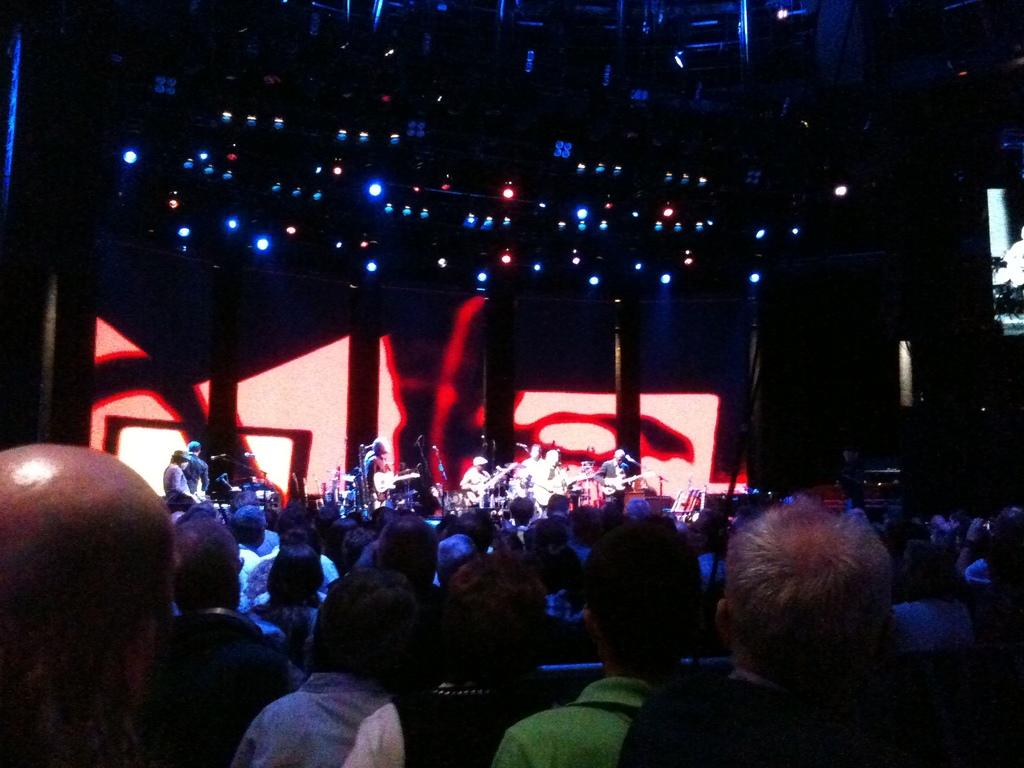How many people are in the image? There are people in the image, but the exact number is not specified. What are some of the people doing in the image? Some people are playing musical instruments on a stage. What equipment is visible in the image that might be used for amplifying sound? There are microphones in the image. What type of furniture is present in the image? There are chairs in the image. What type of lighting is present in the image? There are lights in the image. What type of vertical structures are present in the image? There are poles in the image. Where can the geese be found in the image? There are no geese present in the image. What type of notebook is being used by the people on stage? There is no notebook visible in the image. 